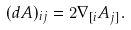Convert formula to latex. <formula><loc_0><loc_0><loc_500><loc_500>( d A ) _ { i j } = 2 \nabla _ { [ i } A _ { j ] } .</formula> 